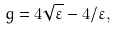<formula> <loc_0><loc_0><loc_500><loc_500>g = 4 \sqrt { \varepsilon } - 4 / \varepsilon ,</formula> 